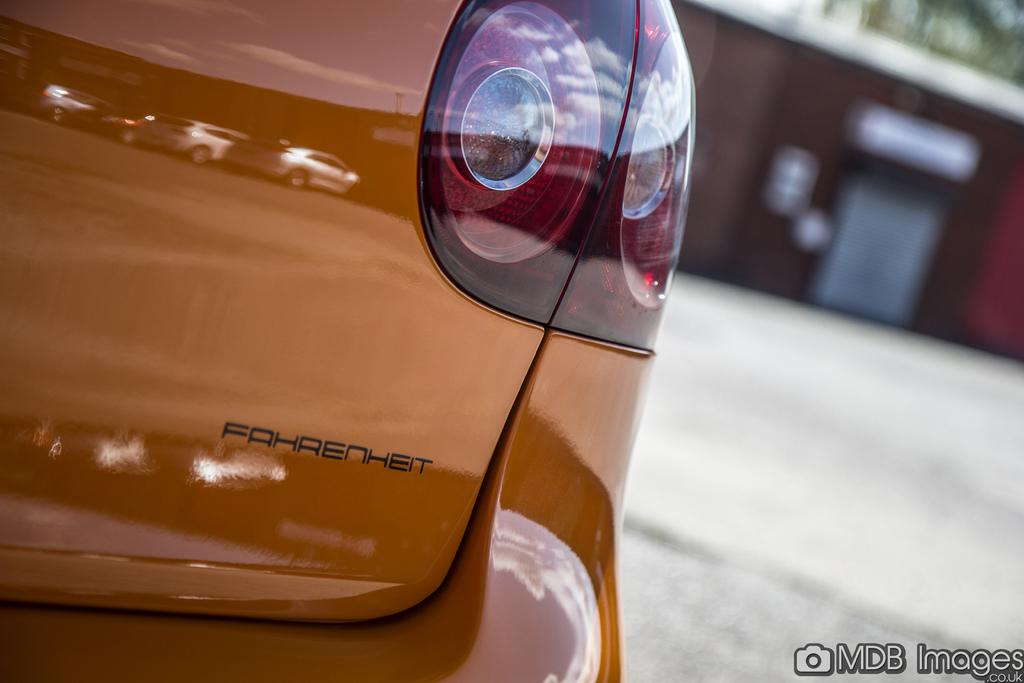What is the main subject of the image? There is a car in the image. Where is the car located in the image? The car is in the center of the image. Can you describe the background of the image? The background of the image is blurry. What type of game is being played in the car in the image? There is no indication of a game being played in the car in the image. 